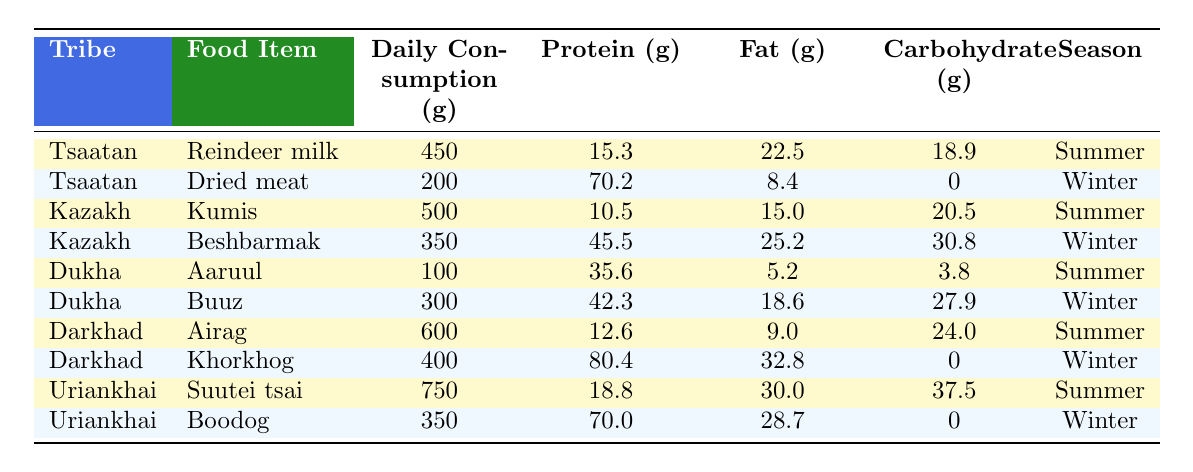What is the daily consumption of Reindeer milk by the Tsaatan tribe? The table shows that the Tsaatan tribe consumes 450 grams of Reindeer milk daily.
Answer: 450 grams Which tribe has the highest daily consumption of a food item in the table? The Uriankhai tribe consumes 750 grams of Suutei tsai, which is the highest in the table compared to all other food items.
Answer: Uriankhai What is the total daily protein intake from Dried meat for the Tsaatan tribe? The table indicates that the protein content from Dried meat is 70.2 grams, which is the only food item listed for the Tsaatan tribe in winter.
Answer: 70.2 grams Does the Dakhar tribe consume more protein during winter than during summer? During winter, the Darkhad tribe consumes 80.4 grams from Khorkhog and during summer consumes 12.6 grams from Airag. Since 80.4 is greater than 12.6, the statement is true.
Answer: Yes What is the difference in daily carbohydrate consumption between Airag and Khorkhog for the Darkhad tribe? The table shows Airag has 24.0 grams of carbohydrates consumed in summer and Khorkhog has 0 grams in winter. The difference is calculated as 24.0 - 0 = 24.0 grams.
Answer: 24.0 grams What is the average daily fat content of the food items for the Dukha tribe? The Dukha tribe consumes 5.2 grams of fat from Aaruul and 18.6 grams from Buuz. Adding them gives 5.2 + 18.6 = 23.8 grams. Dividing by the two food items results in an average of 23.8 / 2 = 11.9 grams.
Answer: 11.9 grams How many food items listed for the Kazakh tribe are consumed in winter? The Kazakh tribe has one food item listed for winter, which is Beshbarmak.
Answer: 1 Which tribe consumes the least daily food quantity in summer? The Dukha tribe has the least quantity of 100 grams from Aaruul in summer. Comparison shows other tribes all consume more than this amount.
Answer: Dukha Is the protein content of Boodog higher or lower than the protein content of Kumis? Boodog has a protein content of 70.0 grams and Kumis has a protein content of 10.5 grams. Since 70.0 is greater than 10.5, Boodog has a higher protein content.
Answer: Higher What is the total daily carbohydrate consumption for all food items consumed by the Uriankhai tribe? The Uriankhai tribe consumes 37.5 grams from Suutei tsai in summer and 0 grams from Boodog in winter. Adding these gives 37.5 + 0 = 37.5 grams.
Answer: 37.5 grams 